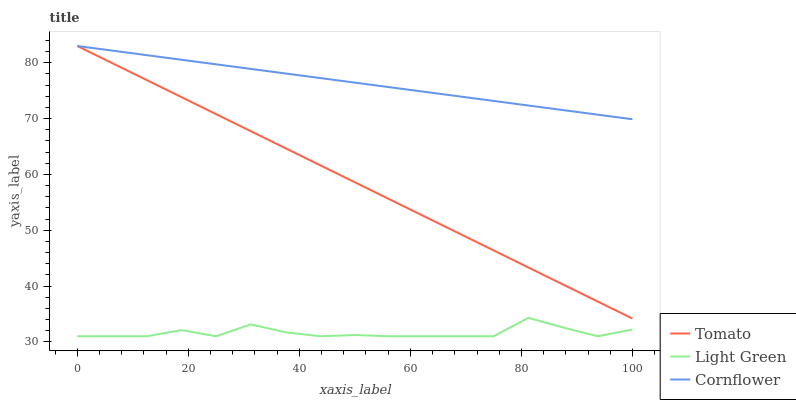Does Light Green have the minimum area under the curve?
Answer yes or no. Yes. Does Cornflower have the maximum area under the curve?
Answer yes or no. Yes. Does Cornflower have the minimum area under the curve?
Answer yes or no. No. Does Light Green have the maximum area under the curve?
Answer yes or no. No. Is Cornflower the smoothest?
Answer yes or no. Yes. Is Light Green the roughest?
Answer yes or no. Yes. Is Light Green the smoothest?
Answer yes or no. No. Is Cornflower the roughest?
Answer yes or no. No. Does Light Green have the lowest value?
Answer yes or no. Yes. Does Cornflower have the lowest value?
Answer yes or no. No. Does Cornflower have the highest value?
Answer yes or no. Yes. Does Light Green have the highest value?
Answer yes or no. No. Is Light Green less than Tomato?
Answer yes or no. Yes. Is Tomato greater than Light Green?
Answer yes or no. Yes. Does Cornflower intersect Tomato?
Answer yes or no. Yes. Is Cornflower less than Tomato?
Answer yes or no. No. Is Cornflower greater than Tomato?
Answer yes or no. No. Does Light Green intersect Tomato?
Answer yes or no. No. 